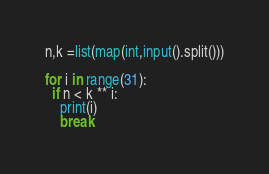<code> <loc_0><loc_0><loc_500><loc_500><_Python_>n,k =list(map(int,input().split()))

for i in range(31):
  if n < k ** i:
    print(i)
    break</code> 